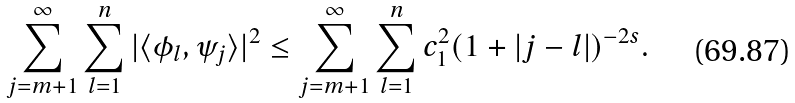Convert formula to latex. <formula><loc_0><loc_0><loc_500><loc_500>\sum _ { j = m + 1 } ^ { \infty } \sum _ { l = 1 } ^ { n } | \langle \phi _ { l } , \psi _ { j } \rangle | ^ { 2 } \leq \sum _ { j = m + 1 } ^ { \infty } \sum _ { l = 1 } ^ { n } c _ { 1 } ^ { 2 } ( 1 + | j - l | ) ^ { - 2 s } .</formula> 